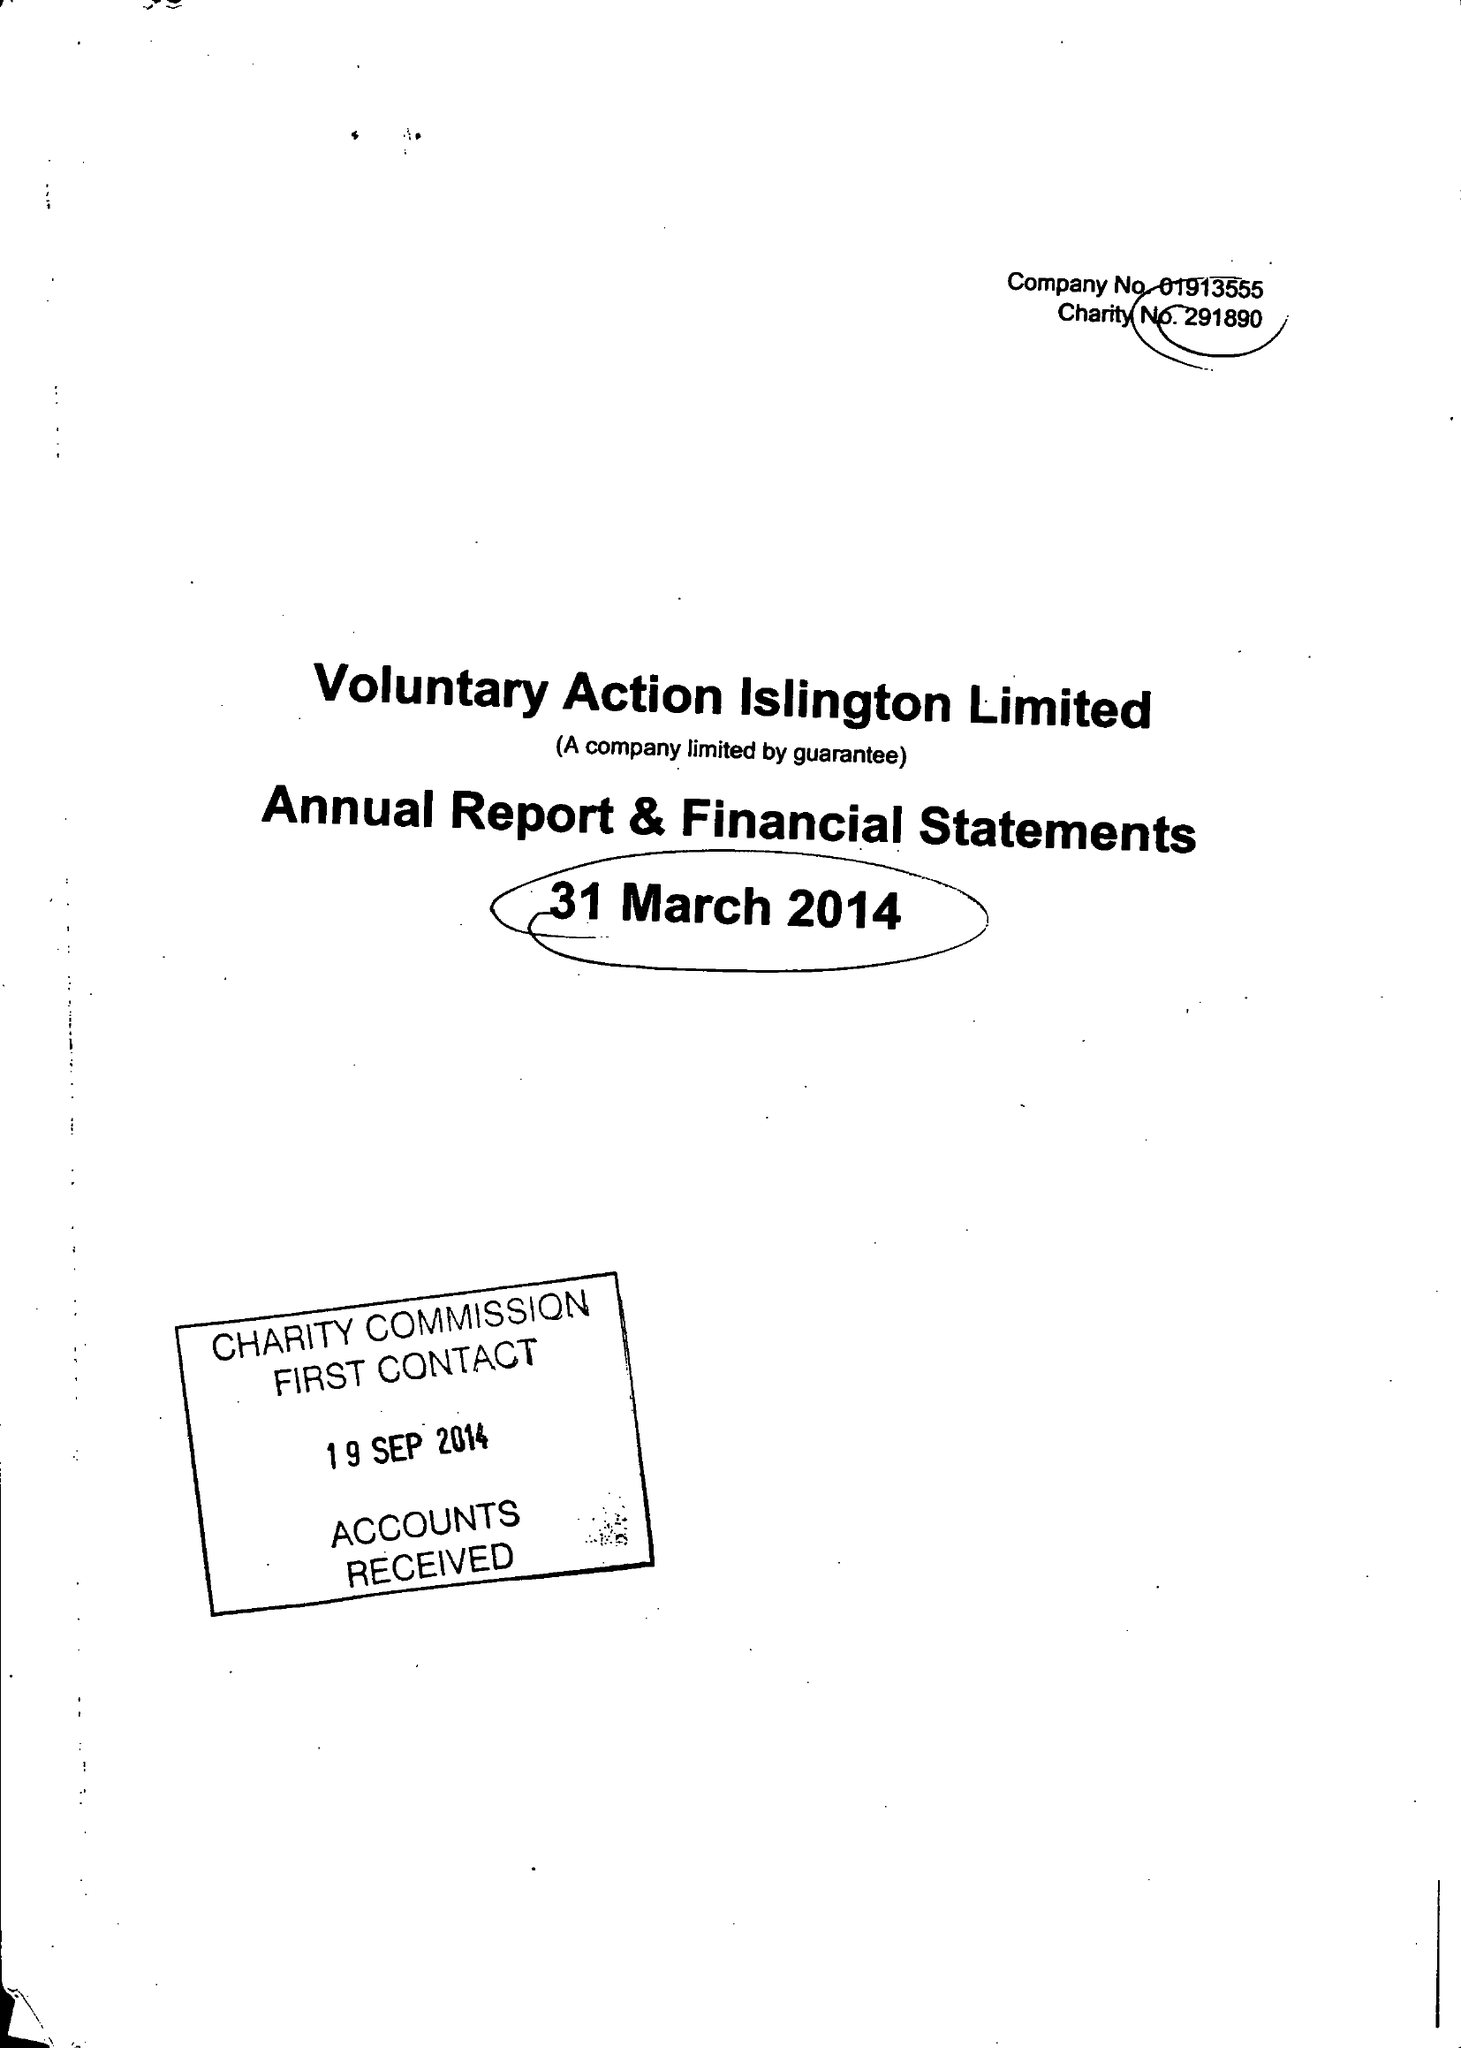What is the value for the income_annually_in_british_pounds?
Answer the question using a single word or phrase. 572702.00 